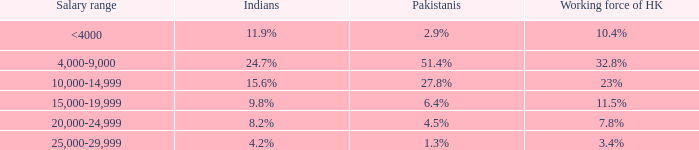If the working force of HK is 10.4%, what is the salary range? <4000. 